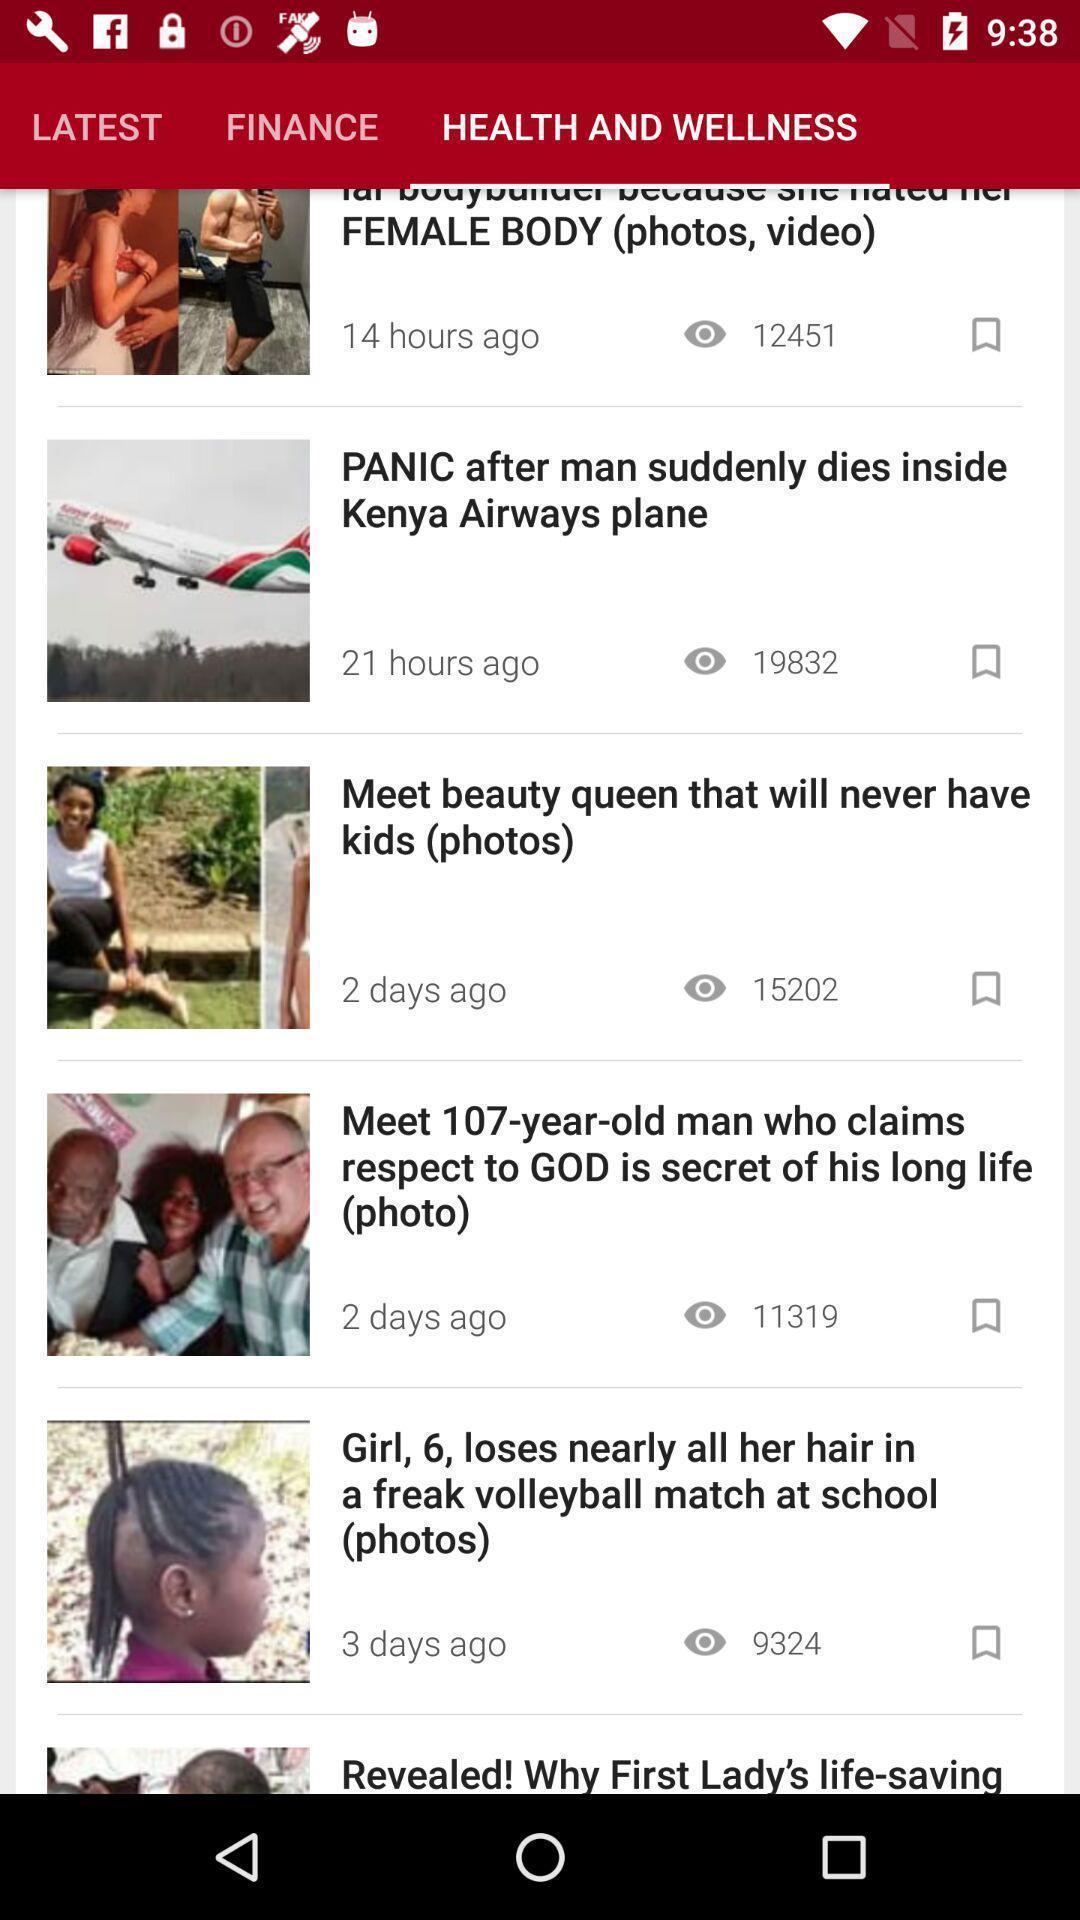What can you discern from this picture? Videos of health and wellness of the social media. 